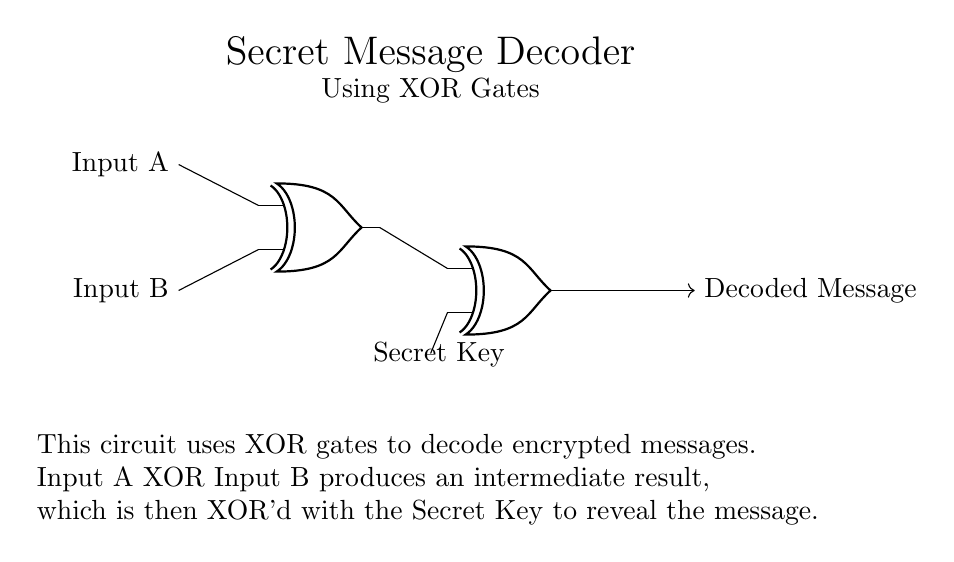What are the inputs to the circuit? The inputs to the circuit are labeled as Input A and Input B, which are both connected to the first XOR gate.
Answer: Input A, Input B How many XOR gates are used in this circuit? There are two XOR gates in the circuit as indicated by the two symbols labeled as 'xor port'.
Answer: Two What is the function of the secret key in this circuit? The secret key is used as the second input for the second XOR gate, which combines with the output of the first XOR gate to decode the message.
Answer: Decoding What does the output of the circuit represent? The output of the circuit is labeled as 'Decoded Message', indicating that it represents the final decoded message after the XOR operations.
Answer: Decoded Message What is the order of operations for decoding the message? The order is first to XOR Input A with Input B, and then XOR the result with the Secret Key. This sequential process reveals the final message.
Answer: XOR A with B, then XOR with Key What would happen if the secret key is changed? Changing the secret key will result in a different output from the circuit because the output relies on the XOR operation with the key; thus, the decoded message will also change.
Answer: Different output How does the circuit ensure secure communication? The circuit ensures secure communication by using XOR gates, which have a specific property that makes the encoded message irreversible without the correct key, thus maintaining confidentiality.
Answer: By using XOR gates 